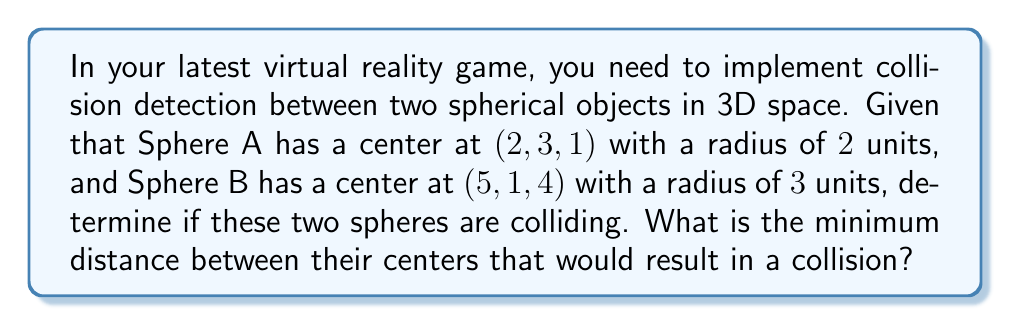Give your solution to this math problem. To determine if two spheres are colliding in 3D space, we need to compare the distance between their centers with the sum of their radii. If the distance is less than or equal to the sum of the radii, the spheres are colliding.

Step 1: Calculate the distance between the centers of the spheres.
We can use the distance formula in 3D space:
$$ d = \sqrt{(x_2-x_1)^2 + (y_2-y_1)^2 + (z_2-z_1)^2} $$

Where $(x_1, y_1, z_1)$ is the center of Sphere A and $(x_2, y_2, z_2)$ is the center of Sphere B.

$$ d = \sqrt{(5-2)^2 + (1-3)^2 + (4-1)^2} $$
$$ d = \sqrt{3^2 + (-2)^2 + 3^2} $$
$$ d = \sqrt{9 + 4 + 9} $$
$$ d = \sqrt{22} \approx 4.69 $$

Step 2: Calculate the sum of the radii.
$$ r_{total} = r_A + r_B = 2 + 3 = 5 $$

Step 3: Compare the distance to the sum of the radii.
Since $d \approx 4.69 < 5 = r_{total}$, the spheres are colliding.

The minimum distance between their centers that would result in a collision is equal to the sum of their radii, which is 5 units.

[asy]
import three;

currentprojection=perspective(6,3,2);
size(200);

triple A = (2,3,1);
triple B = (5,1,4);

draw(A--B,blue);
draw(scale3(2)*unitsphere,shifted(A),red+opacity(0.3));
draw(scale3(3)*unitsphere,shifted(B),green+opacity(0.3));

dot(A,red);
dot(B,green);

label("A",A,N);
label("B",B,S);
[/asy]
Answer: The spheres are colliding. The minimum distance between their centers that would result in a collision is 5 units. 